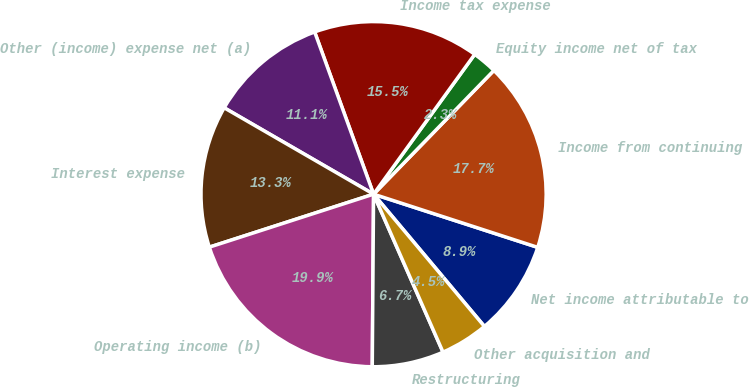<chart> <loc_0><loc_0><loc_500><loc_500><pie_chart><fcel>Net income attributable to<fcel>Income from continuing<fcel>Equity income net of tax<fcel>Income tax expense<fcel>Other (income) expense net (a)<fcel>Interest expense<fcel>Operating income (b)<fcel>Restructuring<fcel>Other acquisition and<nl><fcel>8.91%<fcel>17.71%<fcel>2.31%<fcel>15.51%<fcel>11.11%<fcel>13.31%<fcel>19.91%<fcel>6.71%<fcel>4.51%<nl></chart> 